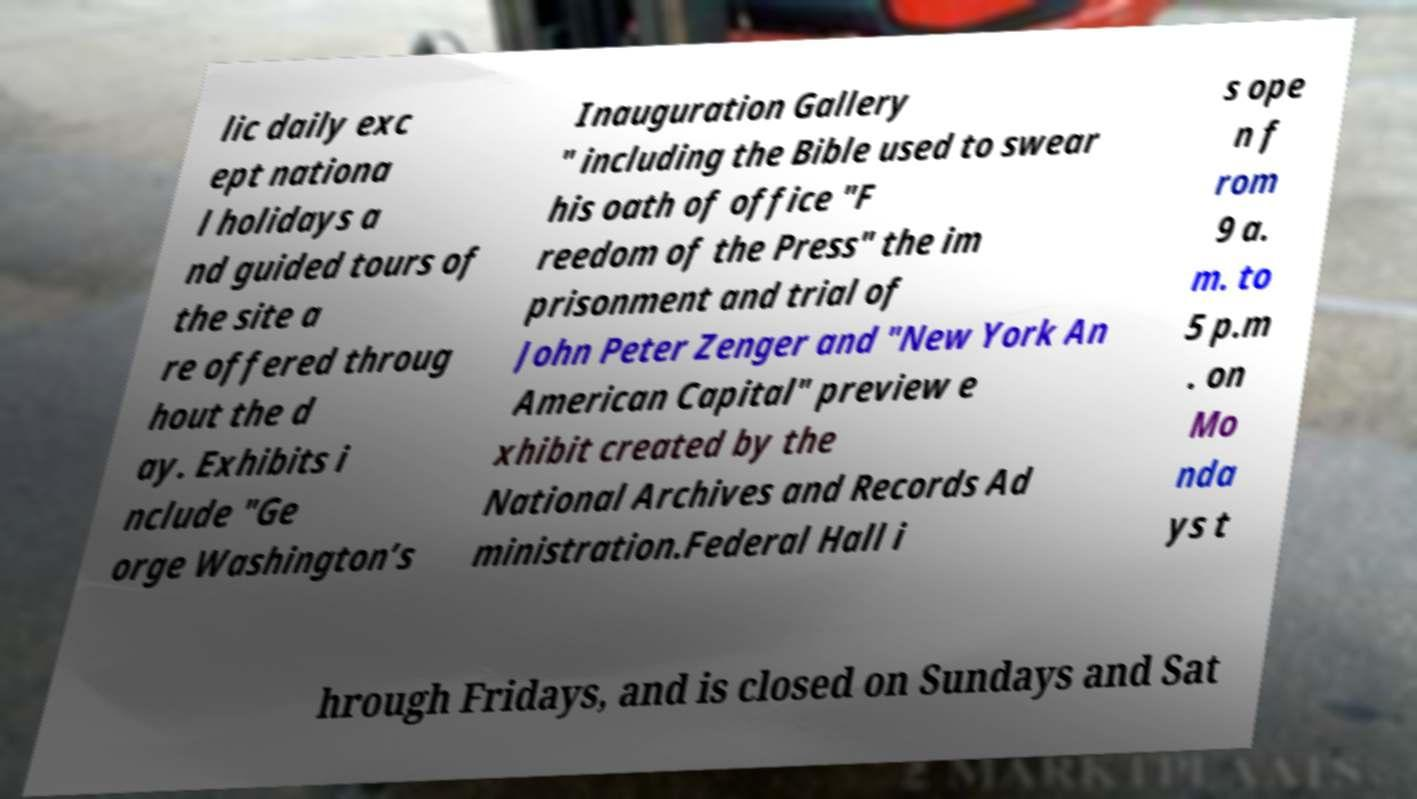What messages or text are displayed in this image? I need them in a readable, typed format. lic daily exc ept nationa l holidays a nd guided tours of the site a re offered throug hout the d ay. Exhibits i nclude "Ge orge Washington’s Inauguration Gallery " including the Bible used to swear his oath of office "F reedom of the Press" the im prisonment and trial of John Peter Zenger and "New York An American Capital" preview e xhibit created by the National Archives and Records Ad ministration.Federal Hall i s ope n f rom 9 a. m. to 5 p.m . on Mo nda ys t hrough Fridays, and is closed on Sundays and Sat 